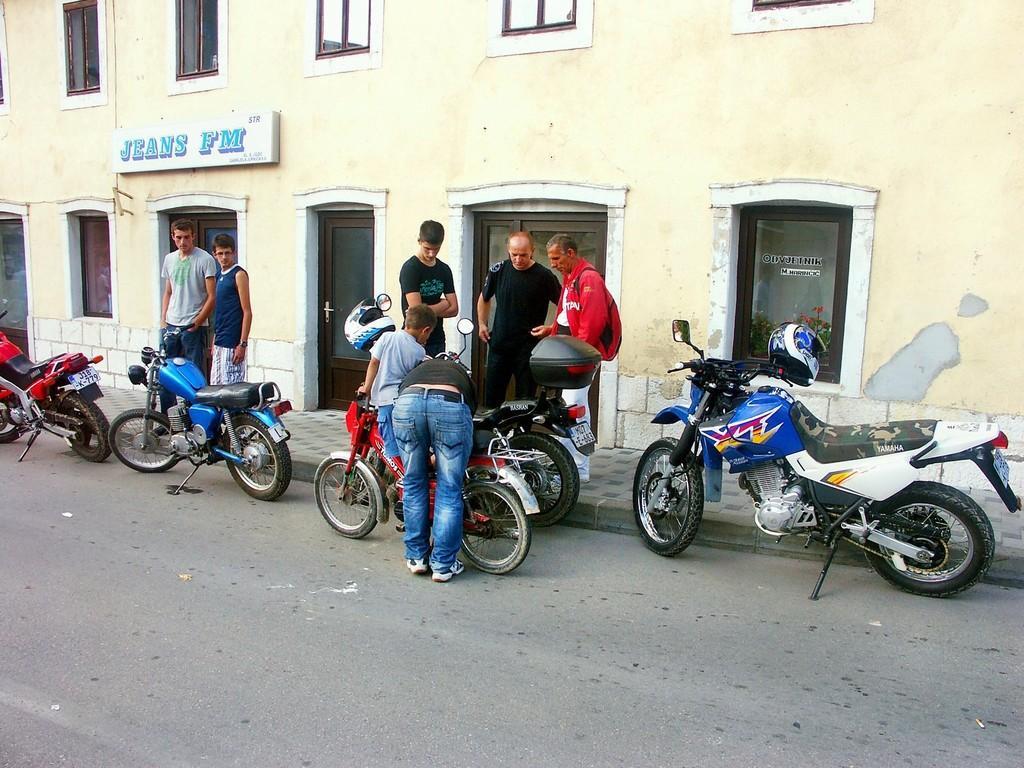Can you describe this image briefly? This image is taken in outdoors. At the bottom of the image there is a road and a few bikes on it. At the top of the image there is a building with doors and windows and a board with text on it. There are few people in this image standing on a road. 